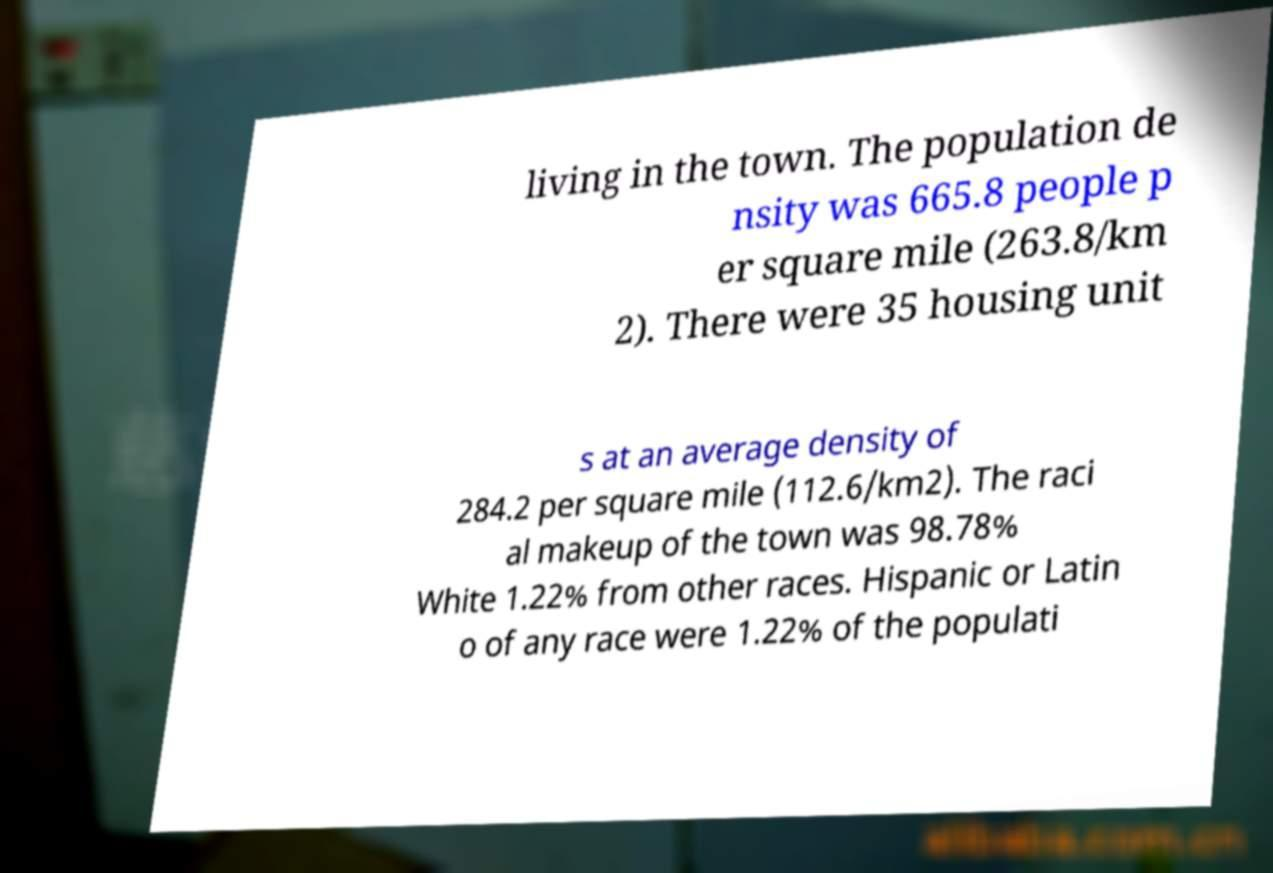For documentation purposes, I need the text within this image transcribed. Could you provide that? living in the town. The population de nsity was 665.8 people p er square mile (263.8/km 2). There were 35 housing unit s at an average density of 284.2 per square mile (112.6/km2). The raci al makeup of the town was 98.78% White 1.22% from other races. Hispanic or Latin o of any race were 1.22% of the populati 